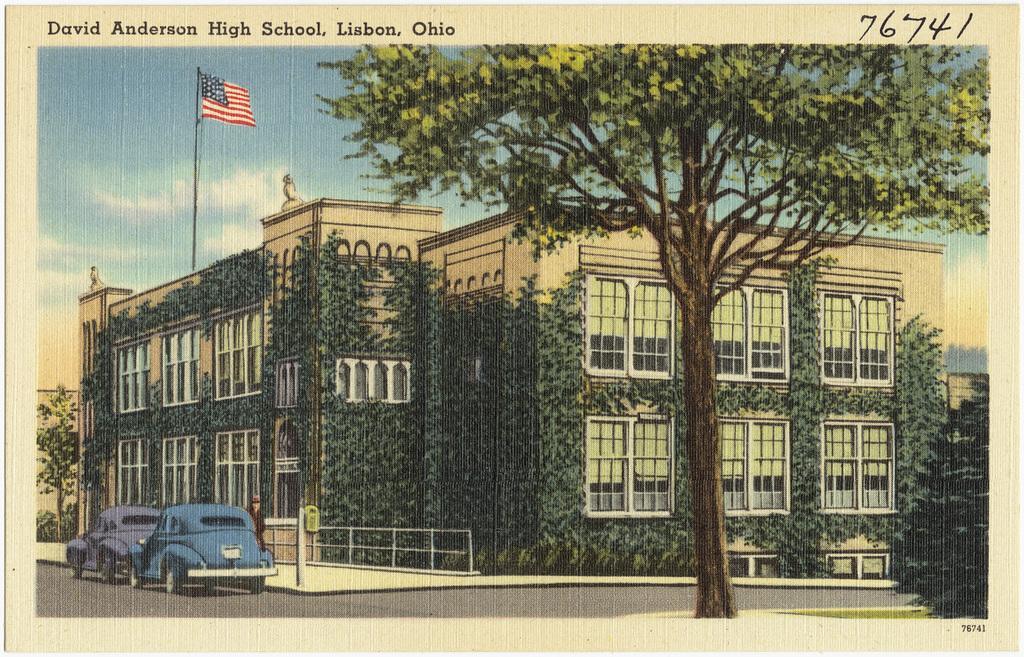Can you describe this image briefly? In this picture we can see a poster, here we can see a person, vehicles on the road and in the background we can see a building, flag, trees, sky, at the top we can see some text and some numbers. 